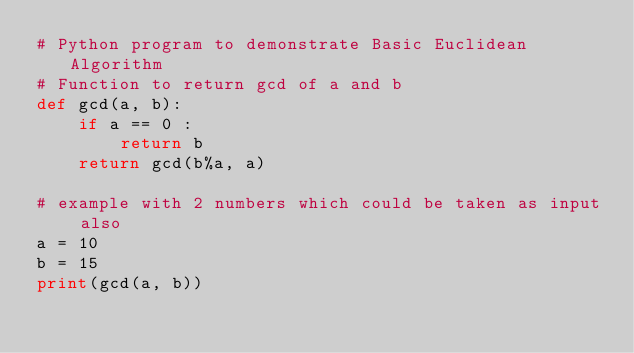<code> <loc_0><loc_0><loc_500><loc_500><_Python_># Python program to demonstrate Basic Euclidean Algorithm 
# Function to return gcd of a and b 
def gcd(a, b):  
    if a == 0 : 
        return b  
    return gcd(b%a, a) 
  
# example with 2 numbers which could be taken as input also
a = 10
b = 15
print(gcd(a, b)) 
</code> 